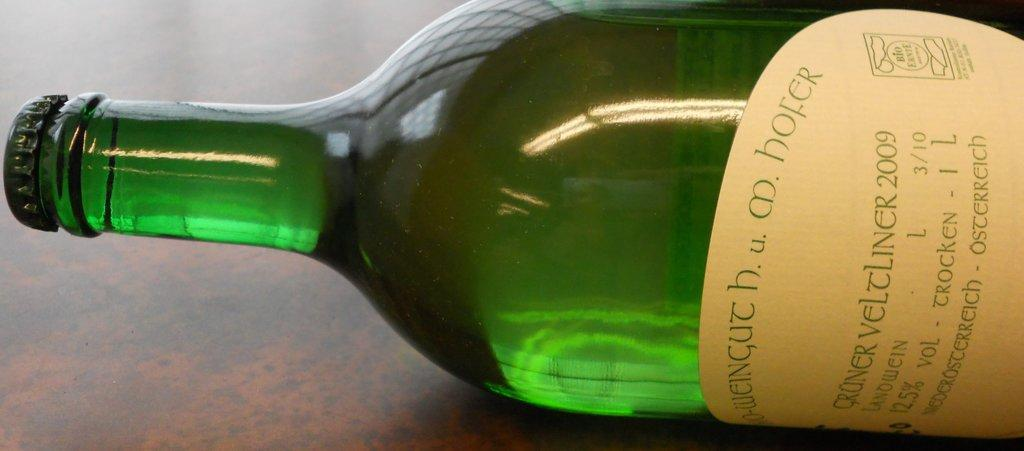<image>
Create a compact narrative representing the image presented. A bottle has the year 2009 on the label. 